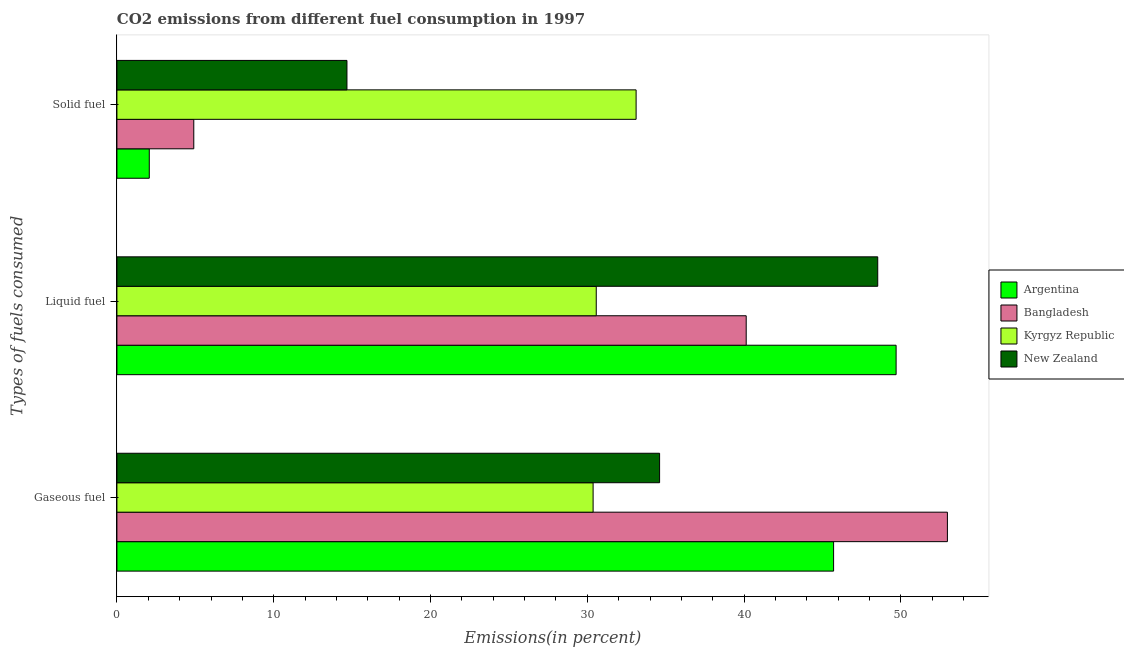How many groups of bars are there?
Offer a very short reply. 3. Are the number of bars on each tick of the Y-axis equal?
Your response must be concise. Yes. How many bars are there on the 3rd tick from the top?
Give a very brief answer. 4. How many bars are there on the 2nd tick from the bottom?
Offer a very short reply. 4. What is the label of the 1st group of bars from the top?
Ensure brevity in your answer.  Solid fuel. What is the percentage of solid fuel emission in New Zealand?
Your answer should be very brief. 14.67. Across all countries, what is the maximum percentage of solid fuel emission?
Offer a terse response. 33.11. Across all countries, what is the minimum percentage of gaseous fuel emission?
Make the answer very short. 30.37. In which country was the percentage of solid fuel emission maximum?
Your response must be concise. Kyrgyz Republic. In which country was the percentage of gaseous fuel emission minimum?
Provide a short and direct response. Kyrgyz Republic. What is the total percentage of liquid fuel emission in the graph?
Offer a very short reply. 168.91. What is the difference between the percentage of liquid fuel emission in Bangladesh and that in Argentina?
Make the answer very short. -9.56. What is the difference between the percentage of gaseous fuel emission in Argentina and the percentage of solid fuel emission in Kyrgyz Republic?
Give a very brief answer. 12.59. What is the average percentage of liquid fuel emission per country?
Provide a succinct answer. 42.23. What is the difference between the percentage of solid fuel emission and percentage of liquid fuel emission in Kyrgyz Republic?
Keep it short and to the point. 2.54. What is the ratio of the percentage of liquid fuel emission in New Zealand to that in Argentina?
Provide a succinct answer. 0.98. Is the percentage of liquid fuel emission in Argentina less than that in New Zealand?
Your response must be concise. No. Is the difference between the percentage of solid fuel emission in Bangladesh and Kyrgyz Republic greater than the difference between the percentage of gaseous fuel emission in Bangladesh and Kyrgyz Republic?
Ensure brevity in your answer.  No. What is the difference between the highest and the second highest percentage of gaseous fuel emission?
Your answer should be compact. 7.26. What is the difference between the highest and the lowest percentage of liquid fuel emission?
Provide a succinct answer. 19.12. In how many countries, is the percentage of liquid fuel emission greater than the average percentage of liquid fuel emission taken over all countries?
Offer a very short reply. 2. What does the 1st bar from the top in Liquid fuel represents?
Make the answer very short. New Zealand. What does the 3rd bar from the bottom in Liquid fuel represents?
Give a very brief answer. Kyrgyz Republic. Is it the case that in every country, the sum of the percentage of gaseous fuel emission and percentage of liquid fuel emission is greater than the percentage of solid fuel emission?
Make the answer very short. Yes. What is the difference between two consecutive major ticks on the X-axis?
Provide a short and direct response. 10. Are the values on the major ticks of X-axis written in scientific E-notation?
Keep it short and to the point. No. Does the graph contain grids?
Your answer should be compact. No. How many legend labels are there?
Offer a terse response. 4. What is the title of the graph?
Make the answer very short. CO2 emissions from different fuel consumption in 1997. Does "Ireland" appear as one of the legend labels in the graph?
Give a very brief answer. No. What is the label or title of the X-axis?
Your answer should be very brief. Emissions(in percent). What is the label or title of the Y-axis?
Keep it short and to the point. Types of fuels consumed. What is the Emissions(in percent) of Argentina in Gaseous fuel?
Your answer should be very brief. 45.7. What is the Emissions(in percent) in Bangladesh in Gaseous fuel?
Give a very brief answer. 52.96. What is the Emissions(in percent) of Kyrgyz Republic in Gaseous fuel?
Your answer should be very brief. 30.37. What is the Emissions(in percent) of New Zealand in Gaseous fuel?
Offer a very short reply. 34.61. What is the Emissions(in percent) in Argentina in Liquid fuel?
Provide a short and direct response. 49.69. What is the Emissions(in percent) in Bangladesh in Liquid fuel?
Your answer should be compact. 40.13. What is the Emissions(in percent) in Kyrgyz Republic in Liquid fuel?
Offer a terse response. 30.57. What is the Emissions(in percent) in New Zealand in Liquid fuel?
Your response must be concise. 48.52. What is the Emissions(in percent) in Argentina in Solid fuel?
Offer a terse response. 2.06. What is the Emissions(in percent) in Bangladesh in Solid fuel?
Offer a terse response. 4.9. What is the Emissions(in percent) of Kyrgyz Republic in Solid fuel?
Ensure brevity in your answer.  33.11. What is the Emissions(in percent) of New Zealand in Solid fuel?
Keep it short and to the point. 14.67. Across all Types of fuels consumed, what is the maximum Emissions(in percent) of Argentina?
Offer a terse response. 49.69. Across all Types of fuels consumed, what is the maximum Emissions(in percent) in Bangladesh?
Provide a succinct answer. 52.96. Across all Types of fuels consumed, what is the maximum Emissions(in percent) of Kyrgyz Republic?
Your answer should be compact. 33.11. Across all Types of fuels consumed, what is the maximum Emissions(in percent) of New Zealand?
Your response must be concise. 48.52. Across all Types of fuels consumed, what is the minimum Emissions(in percent) of Argentina?
Make the answer very short. 2.06. Across all Types of fuels consumed, what is the minimum Emissions(in percent) in Bangladesh?
Provide a succinct answer. 4.9. Across all Types of fuels consumed, what is the minimum Emissions(in percent) of Kyrgyz Republic?
Ensure brevity in your answer.  30.37. Across all Types of fuels consumed, what is the minimum Emissions(in percent) of New Zealand?
Offer a terse response. 14.67. What is the total Emissions(in percent) of Argentina in the graph?
Make the answer very short. 97.46. What is the total Emissions(in percent) in Bangladesh in the graph?
Offer a very short reply. 98. What is the total Emissions(in percent) in Kyrgyz Republic in the graph?
Your answer should be very brief. 94.05. What is the total Emissions(in percent) in New Zealand in the graph?
Your answer should be compact. 97.8. What is the difference between the Emissions(in percent) of Argentina in Gaseous fuel and that in Liquid fuel?
Ensure brevity in your answer.  -3.99. What is the difference between the Emissions(in percent) of Bangladesh in Gaseous fuel and that in Liquid fuel?
Your answer should be very brief. 12.83. What is the difference between the Emissions(in percent) of Kyrgyz Republic in Gaseous fuel and that in Liquid fuel?
Offer a terse response. -0.2. What is the difference between the Emissions(in percent) in New Zealand in Gaseous fuel and that in Liquid fuel?
Your answer should be compact. -13.91. What is the difference between the Emissions(in percent) in Argentina in Gaseous fuel and that in Solid fuel?
Your answer should be very brief. 43.64. What is the difference between the Emissions(in percent) of Bangladesh in Gaseous fuel and that in Solid fuel?
Provide a succinct answer. 48.06. What is the difference between the Emissions(in percent) of Kyrgyz Republic in Gaseous fuel and that in Solid fuel?
Your answer should be compact. -2.74. What is the difference between the Emissions(in percent) of New Zealand in Gaseous fuel and that in Solid fuel?
Give a very brief answer. 19.94. What is the difference between the Emissions(in percent) of Argentina in Liquid fuel and that in Solid fuel?
Your response must be concise. 47.63. What is the difference between the Emissions(in percent) of Bangladesh in Liquid fuel and that in Solid fuel?
Keep it short and to the point. 35.23. What is the difference between the Emissions(in percent) of Kyrgyz Republic in Liquid fuel and that in Solid fuel?
Give a very brief answer. -2.54. What is the difference between the Emissions(in percent) in New Zealand in Liquid fuel and that in Solid fuel?
Make the answer very short. 33.85. What is the difference between the Emissions(in percent) in Argentina in Gaseous fuel and the Emissions(in percent) in Bangladesh in Liquid fuel?
Your response must be concise. 5.57. What is the difference between the Emissions(in percent) in Argentina in Gaseous fuel and the Emissions(in percent) in Kyrgyz Republic in Liquid fuel?
Give a very brief answer. 15.14. What is the difference between the Emissions(in percent) in Argentina in Gaseous fuel and the Emissions(in percent) in New Zealand in Liquid fuel?
Give a very brief answer. -2.82. What is the difference between the Emissions(in percent) in Bangladesh in Gaseous fuel and the Emissions(in percent) in Kyrgyz Republic in Liquid fuel?
Provide a short and direct response. 22.39. What is the difference between the Emissions(in percent) of Bangladesh in Gaseous fuel and the Emissions(in percent) of New Zealand in Liquid fuel?
Your answer should be compact. 4.44. What is the difference between the Emissions(in percent) in Kyrgyz Republic in Gaseous fuel and the Emissions(in percent) in New Zealand in Liquid fuel?
Offer a very short reply. -18.15. What is the difference between the Emissions(in percent) of Argentina in Gaseous fuel and the Emissions(in percent) of Bangladesh in Solid fuel?
Your response must be concise. 40.8. What is the difference between the Emissions(in percent) in Argentina in Gaseous fuel and the Emissions(in percent) in Kyrgyz Republic in Solid fuel?
Your answer should be very brief. 12.59. What is the difference between the Emissions(in percent) of Argentina in Gaseous fuel and the Emissions(in percent) of New Zealand in Solid fuel?
Provide a succinct answer. 31.04. What is the difference between the Emissions(in percent) of Bangladesh in Gaseous fuel and the Emissions(in percent) of Kyrgyz Republic in Solid fuel?
Provide a succinct answer. 19.85. What is the difference between the Emissions(in percent) in Bangladesh in Gaseous fuel and the Emissions(in percent) in New Zealand in Solid fuel?
Your answer should be very brief. 38.29. What is the difference between the Emissions(in percent) of Kyrgyz Republic in Gaseous fuel and the Emissions(in percent) of New Zealand in Solid fuel?
Ensure brevity in your answer.  15.7. What is the difference between the Emissions(in percent) in Argentina in Liquid fuel and the Emissions(in percent) in Bangladesh in Solid fuel?
Make the answer very short. 44.79. What is the difference between the Emissions(in percent) of Argentina in Liquid fuel and the Emissions(in percent) of Kyrgyz Republic in Solid fuel?
Provide a short and direct response. 16.58. What is the difference between the Emissions(in percent) in Argentina in Liquid fuel and the Emissions(in percent) in New Zealand in Solid fuel?
Give a very brief answer. 35.02. What is the difference between the Emissions(in percent) in Bangladesh in Liquid fuel and the Emissions(in percent) in Kyrgyz Republic in Solid fuel?
Offer a terse response. 7.02. What is the difference between the Emissions(in percent) in Bangladesh in Liquid fuel and the Emissions(in percent) in New Zealand in Solid fuel?
Your answer should be compact. 25.46. What is the difference between the Emissions(in percent) in Kyrgyz Republic in Liquid fuel and the Emissions(in percent) in New Zealand in Solid fuel?
Give a very brief answer. 15.9. What is the average Emissions(in percent) of Argentina per Types of fuels consumed?
Provide a succinct answer. 32.49. What is the average Emissions(in percent) of Bangladesh per Types of fuels consumed?
Give a very brief answer. 32.67. What is the average Emissions(in percent) of Kyrgyz Republic per Types of fuels consumed?
Make the answer very short. 31.35. What is the average Emissions(in percent) in New Zealand per Types of fuels consumed?
Offer a terse response. 32.6. What is the difference between the Emissions(in percent) in Argentina and Emissions(in percent) in Bangladesh in Gaseous fuel?
Offer a terse response. -7.26. What is the difference between the Emissions(in percent) of Argentina and Emissions(in percent) of Kyrgyz Republic in Gaseous fuel?
Provide a succinct answer. 15.34. What is the difference between the Emissions(in percent) of Argentina and Emissions(in percent) of New Zealand in Gaseous fuel?
Ensure brevity in your answer.  11.1. What is the difference between the Emissions(in percent) of Bangladesh and Emissions(in percent) of Kyrgyz Republic in Gaseous fuel?
Your answer should be very brief. 22.59. What is the difference between the Emissions(in percent) in Bangladesh and Emissions(in percent) in New Zealand in Gaseous fuel?
Your answer should be very brief. 18.35. What is the difference between the Emissions(in percent) of Kyrgyz Republic and Emissions(in percent) of New Zealand in Gaseous fuel?
Offer a terse response. -4.24. What is the difference between the Emissions(in percent) of Argentina and Emissions(in percent) of Bangladesh in Liquid fuel?
Make the answer very short. 9.56. What is the difference between the Emissions(in percent) of Argentina and Emissions(in percent) of Kyrgyz Republic in Liquid fuel?
Provide a succinct answer. 19.12. What is the difference between the Emissions(in percent) in Argentina and Emissions(in percent) in New Zealand in Liquid fuel?
Give a very brief answer. 1.17. What is the difference between the Emissions(in percent) in Bangladesh and Emissions(in percent) in Kyrgyz Republic in Liquid fuel?
Your response must be concise. 9.56. What is the difference between the Emissions(in percent) in Bangladesh and Emissions(in percent) in New Zealand in Liquid fuel?
Provide a succinct answer. -8.39. What is the difference between the Emissions(in percent) of Kyrgyz Republic and Emissions(in percent) of New Zealand in Liquid fuel?
Your response must be concise. -17.95. What is the difference between the Emissions(in percent) of Argentina and Emissions(in percent) of Bangladesh in Solid fuel?
Give a very brief answer. -2.84. What is the difference between the Emissions(in percent) in Argentina and Emissions(in percent) in Kyrgyz Republic in Solid fuel?
Your answer should be very brief. -31.05. What is the difference between the Emissions(in percent) of Argentina and Emissions(in percent) of New Zealand in Solid fuel?
Give a very brief answer. -12.61. What is the difference between the Emissions(in percent) in Bangladesh and Emissions(in percent) in Kyrgyz Republic in Solid fuel?
Keep it short and to the point. -28.21. What is the difference between the Emissions(in percent) of Bangladesh and Emissions(in percent) of New Zealand in Solid fuel?
Provide a succinct answer. -9.77. What is the difference between the Emissions(in percent) in Kyrgyz Republic and Emissions(in percent) in New Zealand in Solid fuel?
Provide a succinct answer. 18.44. What is the ratio of the Emissions(in percent) of Argentina in Gaseous fuel to that in Liquid fuel?
Provide a succinct answer. 0.92. What is the ratio of the Emissions(in percent) in Bangladesh in Gaseous fuel to that in Liquid fuel?
Your answer should be compact. 1.32. What is the ratio of the Emissions(in percent) in Kyrgyz Republic in Gaseous fuel to that in Liquid fuel?
Keep it short and to the point. 0.99. What is the ratio of the Emissions(in percent) in New Zealand in Gaseous fuel to that in Liquid fuel?
Offer a very short reply. 0.71. What is the ratio of the Emissions(in percent) of Argentina in Gaseous fuel to that in Solid fuel?
Ensure brevity in your answer.  22.15. What is the ratio of the Emissions(in percent) in Bangladesh in Gaseous fuel to that in Solid fuel?
Provide a short and direct response. 10.81. What is the ratio of the Emissions(in percent) of Kyrgyz Republic in Gaseous fuel to that in Solid fuel?
Offer a terse response. 0.92. What is the ratio of the Emissions(in percent) of New Zealand in Gaseous fuel to that in Solid fuel?
Give a very brief answer. 2.36. What is the ratio of the Emissions(in percent) in Argentina in Liquid fuel to that in Solid fuel?
Provide a succinct answer. 24.08. What is the ratio of the Emissions(in percent) in Bangladesh in Liquid fuel to that in Solid fuel?
Offer a terse response. 8.19. What is the ratio of the Emissions(in percent) of Kyrgyz Republic in Liquid fuel to that in Solid fuel?
Your answer should be very brief. 0.92. What is the ratio of the Emissions(in percent) in New Zealand in Liquid fuel to that in Solid fuel?
Give a very brief answer. 3.31. What is the difference between the highest and the second highest Emissions(in percent) in Argentina?
Give a very brief answer. 3.99. What is the difference between the highest and the second highest Emissions(in percent) of Bangladesh?
Offer a terse response. 12.83. What is the difference between the highest and the second highest Emissions(in percent) of Kyrgyz Republic?
Your response must be concise. 2.54. What is the difference between the highest and the second highest Emissions(in percent) in New Zealand?
Make the answer very short. 13.91. What is the difference between the highest and the lowest Emissions(in percent) in Argentina?
Ensure brevity in your answer.  47.63. What is the difference between the highest and the lowest Emissions(in percent) of Bangladesh?
Your answer should be very brief. 48.06. What is the difference between the highest and the lowest Emissions(in percent) in Kyrgyz Republic?
Your answer should be compact. 2.74. What is the difference between the highest and the lowest Emissions(in percent) in New Zealand?
Offer a terse response. 33.85. 